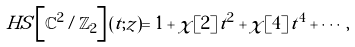<formula> <loc_0><loc_0><loc_500><loc_500>H S \left [ \mathbb { C } ^ { 2 } / \mathbb { Z } _ { 2 } \right ] ( t ; z ) = 1 + \chi [ 2 ] \, t ^ { 2 } + \chi [ 4 ] \, t ^ { 4 } + \cdots \, ,</formula> 